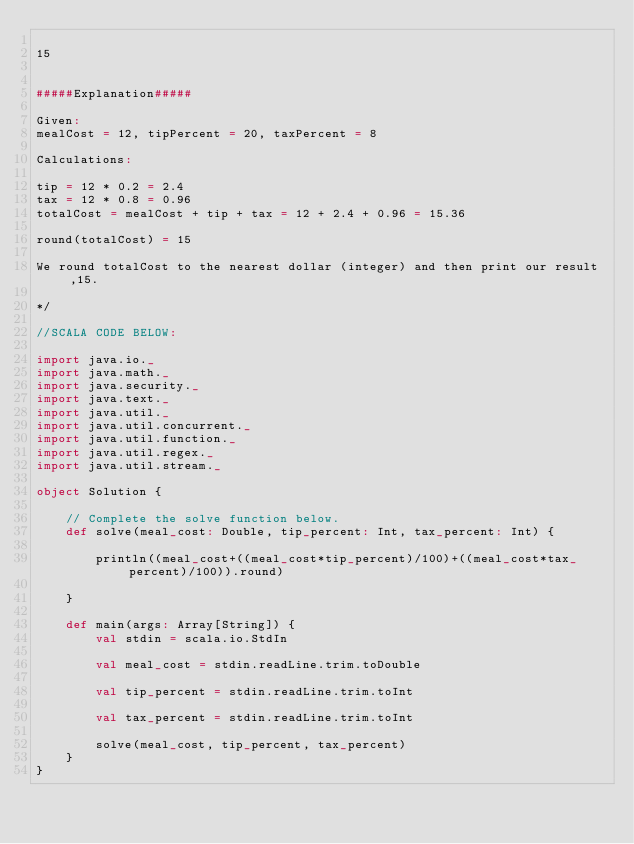<code> <loc_0><loc_0><loc_500><loc_500><_Scala_>
15


#####Explanation#####

Given:
mealCost = 12, tipPercent = 20, taxPercent = 8

Calculations:

tip = 12 * 0.2 = 2.4
tax = 12 * 0.8 = 0.96
totalCost = mealCost + tip + tax = 12 + 2.4 + 0.96 = 15.36

round(totalCost) = 15

We round totalCost to the nearest dollar (integer) and then print our result,15.

*/

//SCALA CODE BELOW:

import java.io._
import java.math._
import java.security._
import java.text._
import java.util._
import java.util.concurrent._
import java.util.function._
import java.util.regex._
import java.util.stream._

object Solution {

    // Complete the solve function below.
    def solve(meal_cost: Double, tip_percent: Int, tax_percent: Int) {
        
        println((meal_cost+((meal_cost*tip_percent)/100)+((meal_cost*tax_percent)/100)).round)

    }

    def main(args: Array[String]) {
        val stdin = scala.io.StdIn

        val meal_cost = stdin.readLine.trim.toDouble

        val tip_percent = stdin.readLine.trim.toInt

        val tax_percent = stdin.readLine.trim.toInt

        solve(meal_cost, tip_percent, tax_percent)
    }
}
</code> 